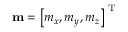Convert formula to latex. <formula><loc_0><loc_0><loc_500><loc_500>m = \left [ m _ { x } , m _ { y } , m _ { z } \right ] ^ { T }</formula> 